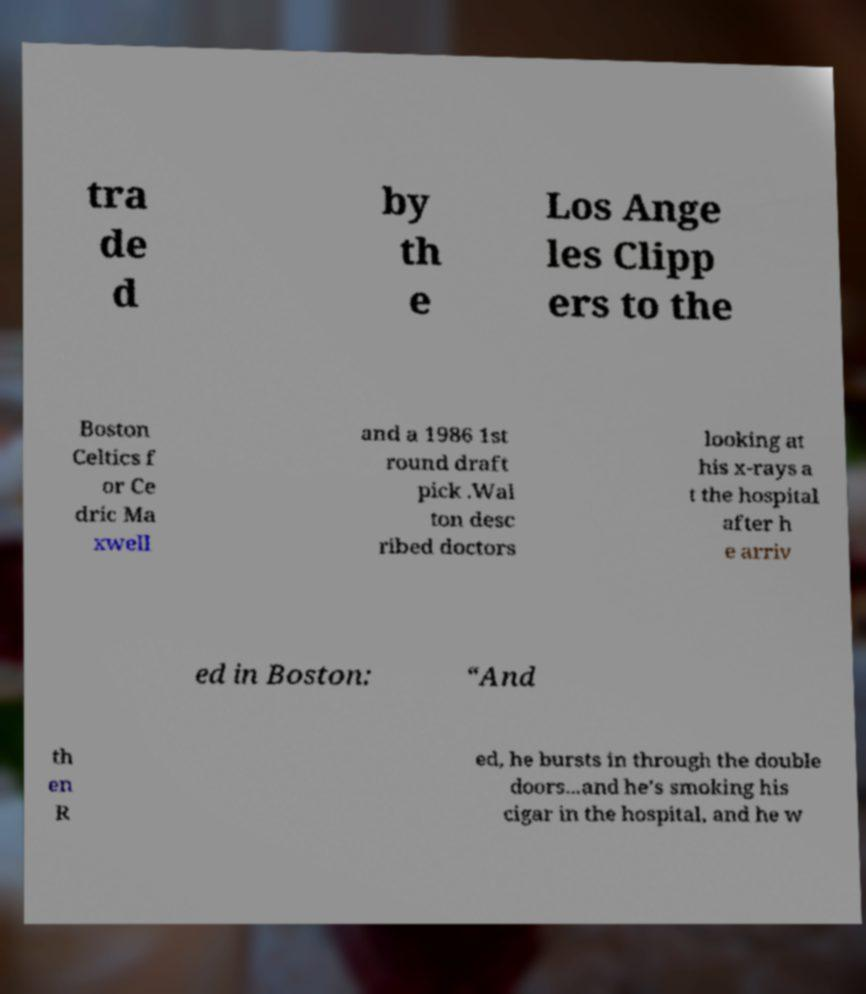I need the written content from this picture converted into text. Can you do that? tra de d by th e Los Ange les Clipp ers to the Boston Celtics f or Ce dric Ma xwell and a 1986 1st round draft pick .Wal ton desc ribed doctors looking at his x-rays a t the hospital after h e arriv ed in Boston: “And th en R ed, he bursts in through the double doors...and he’s smoking his cigar in the hospital, and he w 